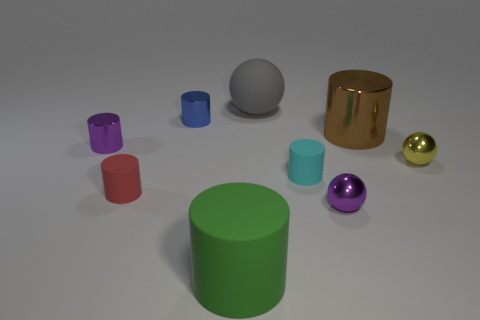Subtract all purple cylinders. How many cylinders are left? 5 Subtract all brown cylinders. How many cylinders are left? 5 Subtract all brown cylinders. Subtract all brown blocks. How many cylinders are left? 5 Subtract all cylinders. How many objects are left? 3 Add 6 tiny purple metal things. How many tiny purple metal things are left? 8 Add 9 large red cubes. How many large red cubes exist? 9 Subtract 1 purple balls. How many objects are left? 8 Subtract all big matte spheres. Subtract all small blue objects. How many objects are left? 7 